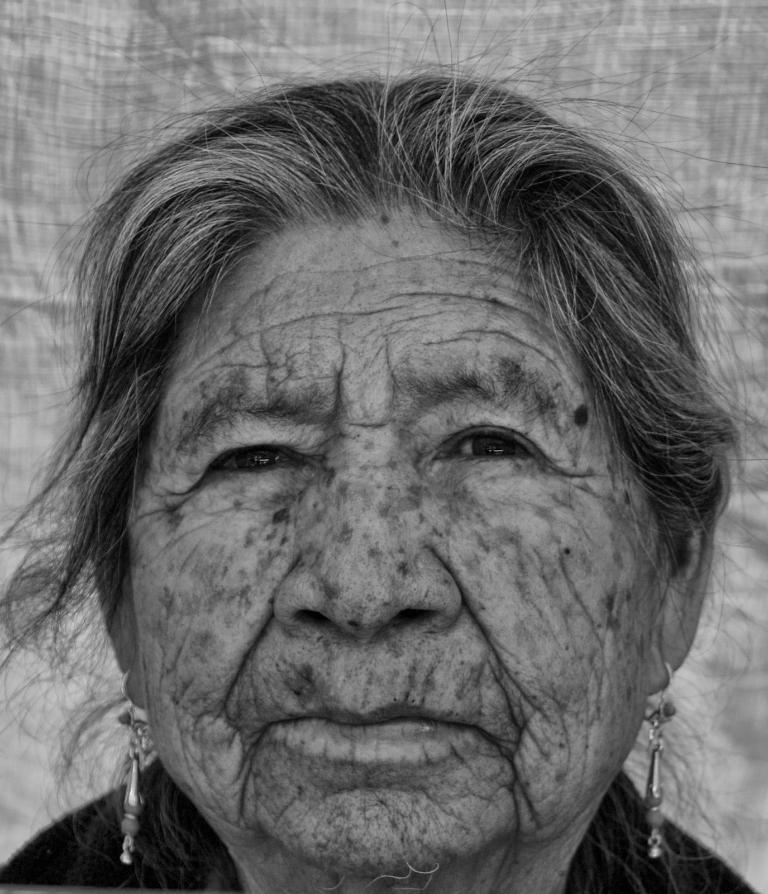What is the color scheme of the image? The image is black and white. Who is present in the image? There is a woman in the image. What type of accessory is the woman wearing? The woman is wearing earrings. What can be seen behind the woman in the image? There is a cloth visible behind the woman in the image. What type of substance is the woman holding in her hand in the image? There is no indication in the image that the woman is holding any substance in her hand. Can you tell me how many times the woman is kissing someone in the image? There is no kissing activity depicted in the image. What is the woman doing with her tongue in the image? There is no indication of the woman using her tongue in any way in the image. 